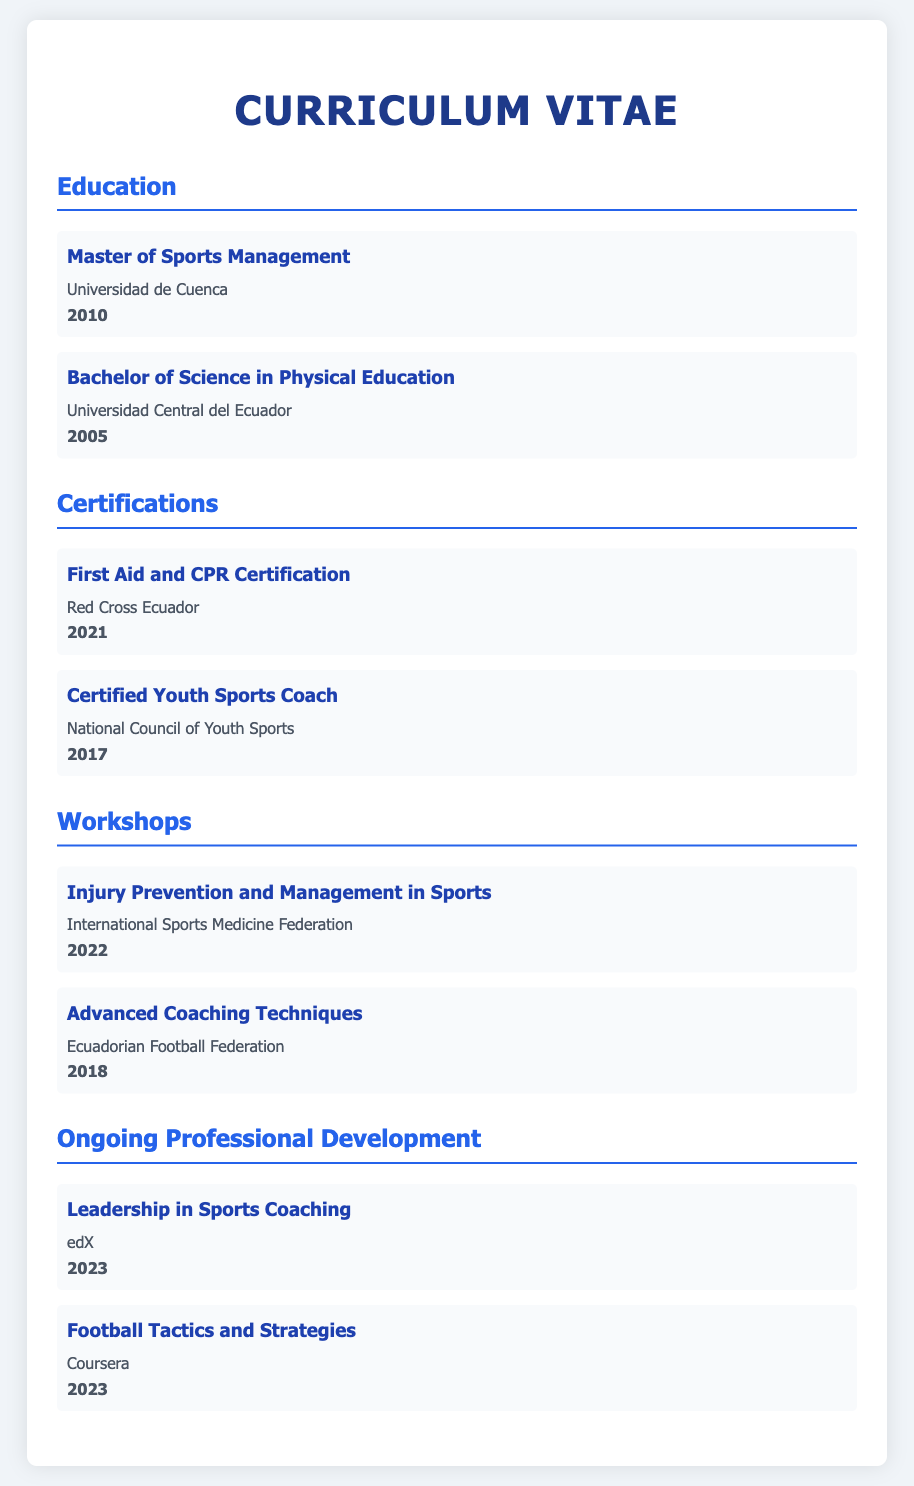What is the highest degree earned? The highest degree listed in the document is "Master of Sports Management" obtained from "Universidad de Cuenca" in 2010.
Answer: Master of Sports Management In what year was the Bachelor of Science in Physical Education awarded? The document states that the Bachelor of Science in Physical Education was awarded in 2005.
Answer: 2005 Which organization provided the First Aid and CPR Certification? The organization responsible for the First Aid and CPR Certification according to the document is the "Red Cross Ecuador."
Answer: Red Cross Ecuador How many ongoing professional development courses are listed? The document lists two ongoing professional development courses under that section.
Answer: 2 What was the subject of the workshop attended in 2022? The workshop attended in 2022 was focused on "Injury Prevention and Management in Sports."
Answer: Injury Prevention and Management in Sports Which certification was obtained in 2017? The certification obtained in 2017 is for "Certified Youth Sports Coach."
Answer: Certified Youth Sports Coach Who conducted the Advanced Coaching Techniques workshop? The Advanced Coaching Techniques workshop was conducted by the "Ecuadorian Football Federation."
Answer: Ecuadorian Football Federation What year did the Leadership in Sports Coaching professional development occur? The Leadership in Sports Coaching course took place in the year 2023.
Answer: 2023 